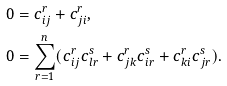<formula> <loc_0><loc_0><loc_500><loc_500>0 & = c _ { i j } ^ { r } + c _ { j i } ^ { r } , \\ 0 & = \sum _ { r = 1 } ^ { n } ( c _ { i j } ^ { r } c _ { l r } ^ { s } + c _ { j k } ^ { r } c _ { i r } ^ { s } + c _ { k i } ^ { r } c _ { j r } ^ { s } ) .</formula> 